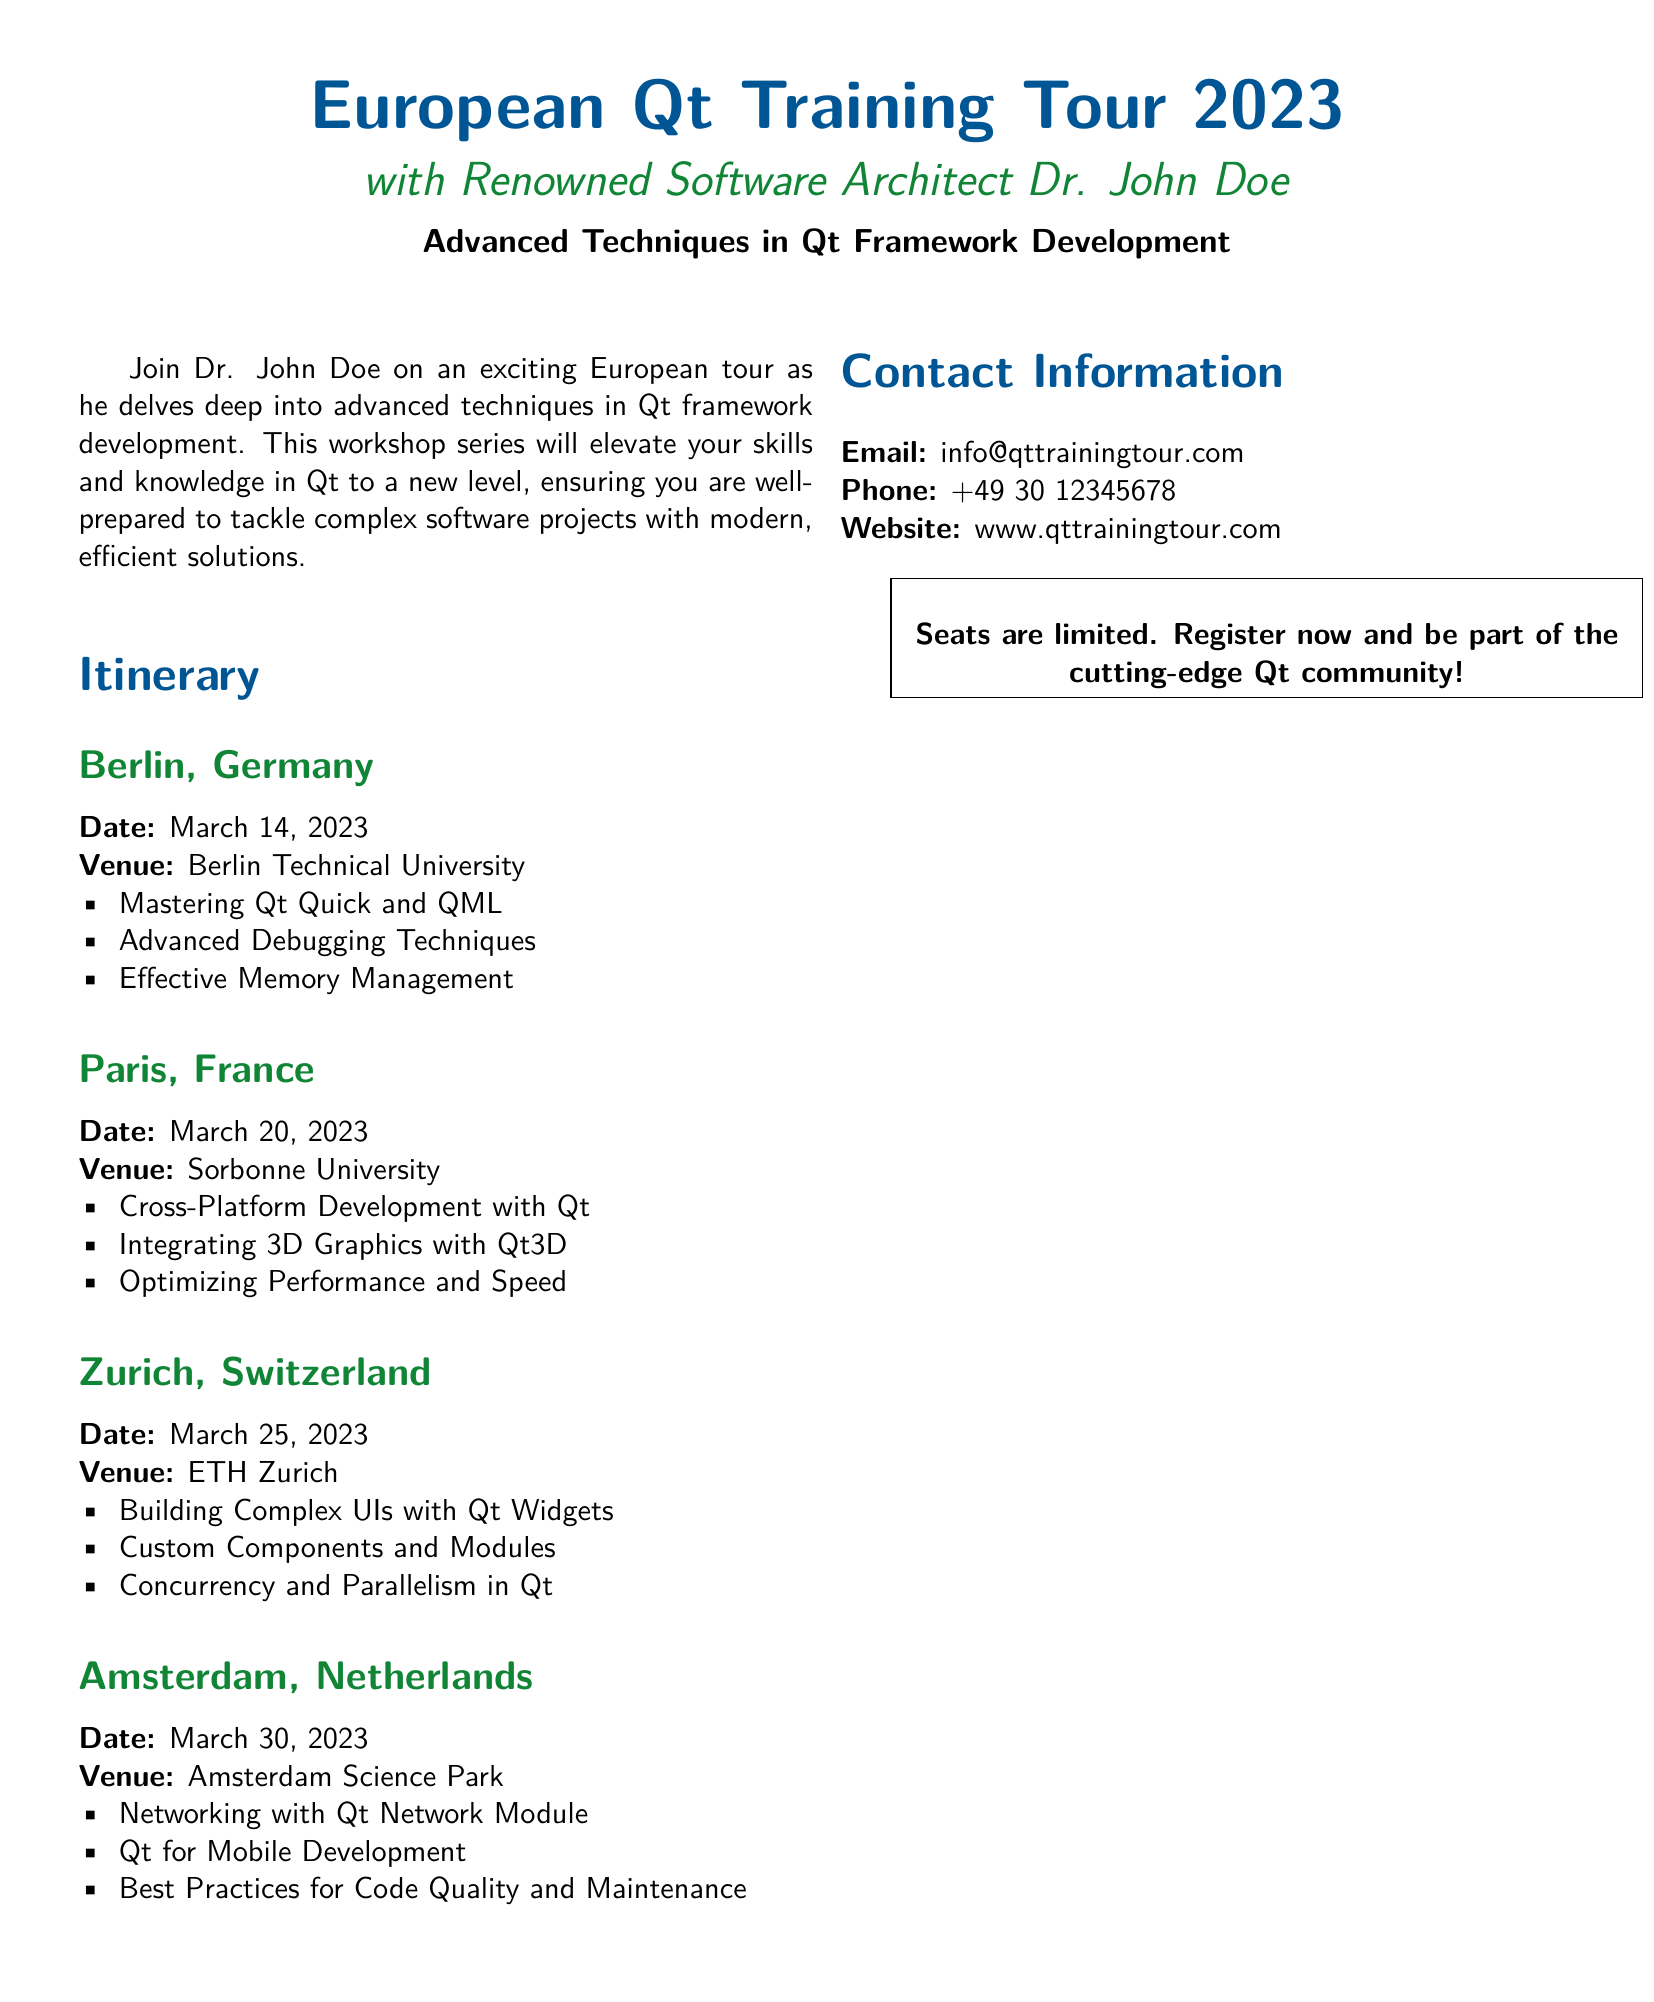What is the date of the Berlin workshop? The date of the Berlin workshop is specified in the itinerary section.
Answer: March 14, 2023 Where is the Paris training session held? The venue for the Paris training session is listed in the itinerary.
Answer: Sorbonne University Which topic covers performance optimization in the workshops? The workshop topic related to performance is mentioned under the Paris session.
Answer: Optimizing Performance and Speed What is the venue for the workshop in Zurich? The venue for the Zurich workshop is detailed in the itinerary section.
Answer: ETH Zurich How many workshops are scheduled in total? The total number of locations with workshops is counted from the itinerary section.
Answer: Four Which topic is covered in Amsterdam related to networking? The networking-related topic is specified in the Amsterdam workshop details.
Answer: Networking with Qt Network Module Who is conducting the Qt Training Tour? The instructor for the Qt Training Tour is stated in the header information.
Answer: Dr. John Doe What type of development is discussed on March 30, 2023? The type of development discussed on this date is indicated in the Amsterdam session.
Answer: Mobile Development What is the contact email for the training tour? The contact email is mentioned in the contact information section of the document.
Answer: info@qttrainingtour.com 